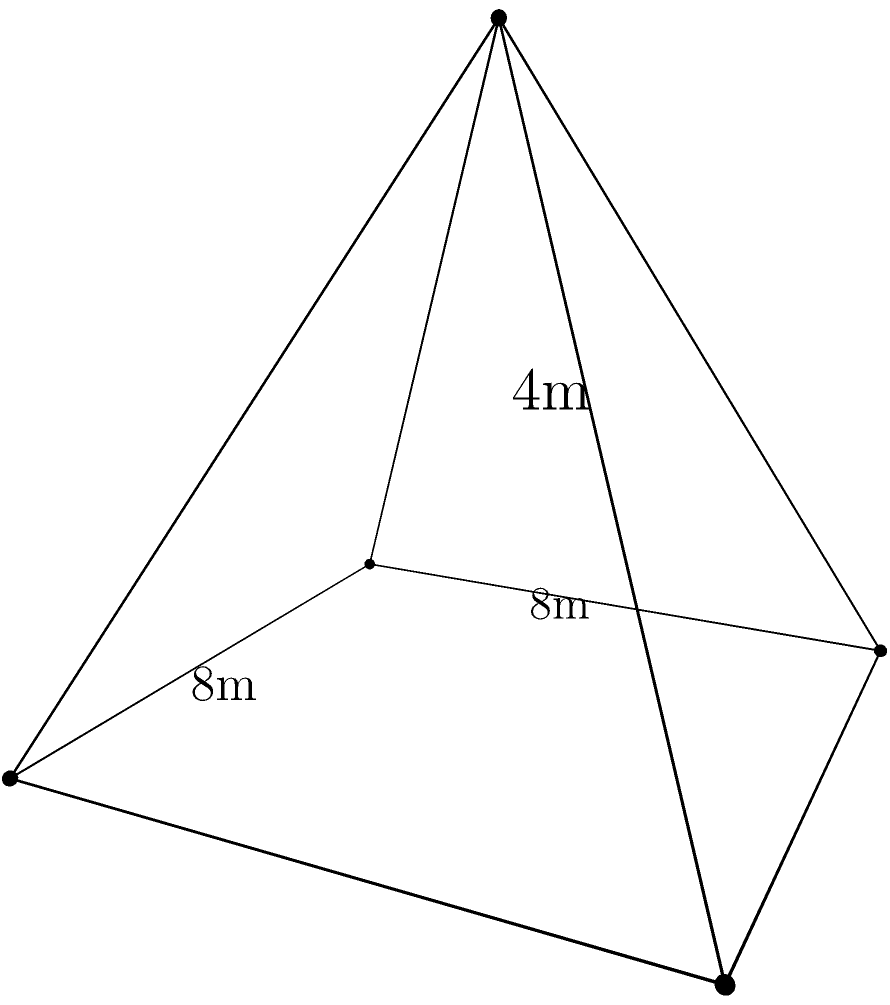During an archaeological excavation, a perfectly square-based pyramid was discovered. The base of the pyramid measures 8 meters on each side, and its height is 4 meters. As part of the restoration process, you need to calculate the volume of this pyramid. What is the volume in cubic meters? To calculate the volume of a pyramid, we use the formula:

$$ V = \frac{1}{3} \times B \times h $$

Where:
- $V$ is the volume
- $B$ is the area of the base
- $h$ is the height of the pyramid

Step 1: Calculate the area of the base (B)
The base is a square with side length 8 meters.
$$ B = 8 \text{ m} \times 8 \text{ m} = 64 \text{ m}^2 $$

Step 2: Apply the volume formula
$$ V = \frac{1}{3} \times 64 \text{ m}^2 \times 4 \text{ m} $$

Step 3: Calculate the result
$$ V = \frac{256}{3} \text{ m}^3 \approx 85.33 \text{ m}^3 $$

Therefore, the volume of the pyramid is approximately 85.33 cubic meters.
Answer: 85.33 m³ 